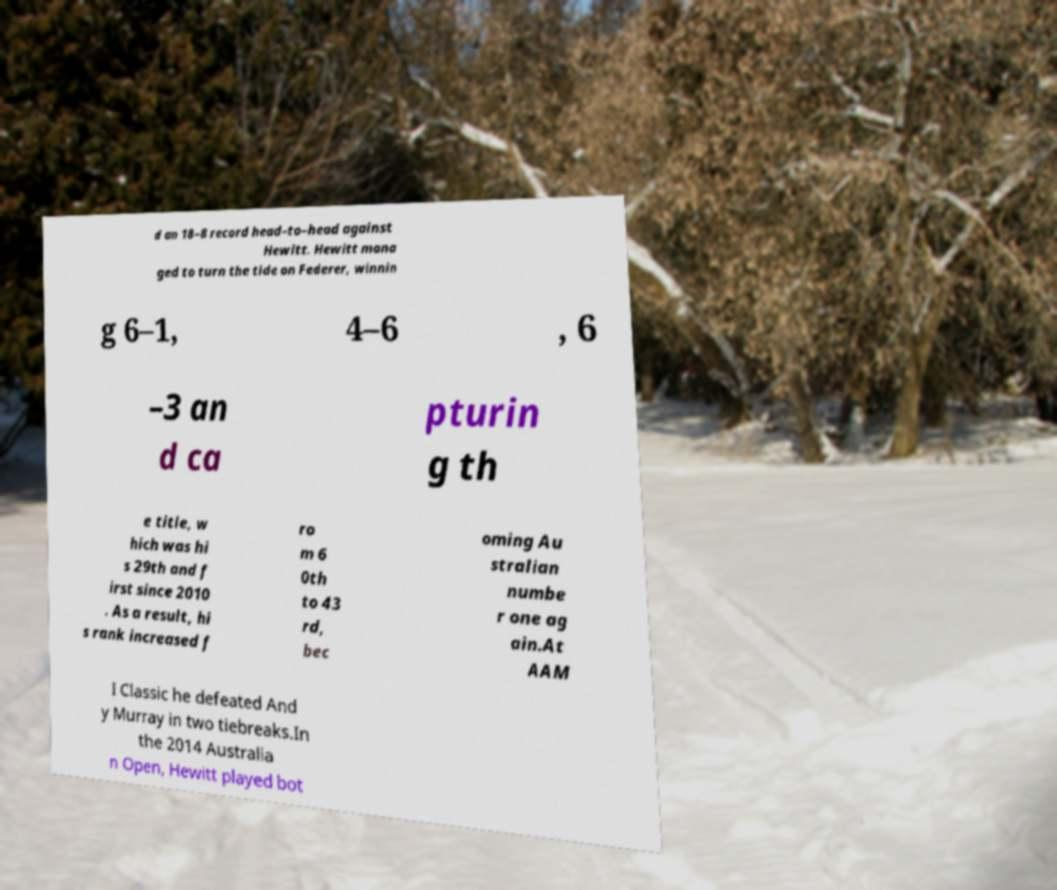Please read and relay the text visible in this image. What does it say? d an 18–8 record head–to–head against Hewitt. Hewitt mana ged to turn the tide on Federer, winnin g 6–1, 4–6 , 6 –3 an d ca pturin g th e title, w hich was hi s 29th and f irst since 2010 . As a result, hi s rank increased f ro m 6 0th to 43 rd, bec oming Au stralian numbe r one ag ain.At AAM I Classic he defeated And y Murray in two tiebreaks.In the 2014 Australia n Open, Hewitt played bot 